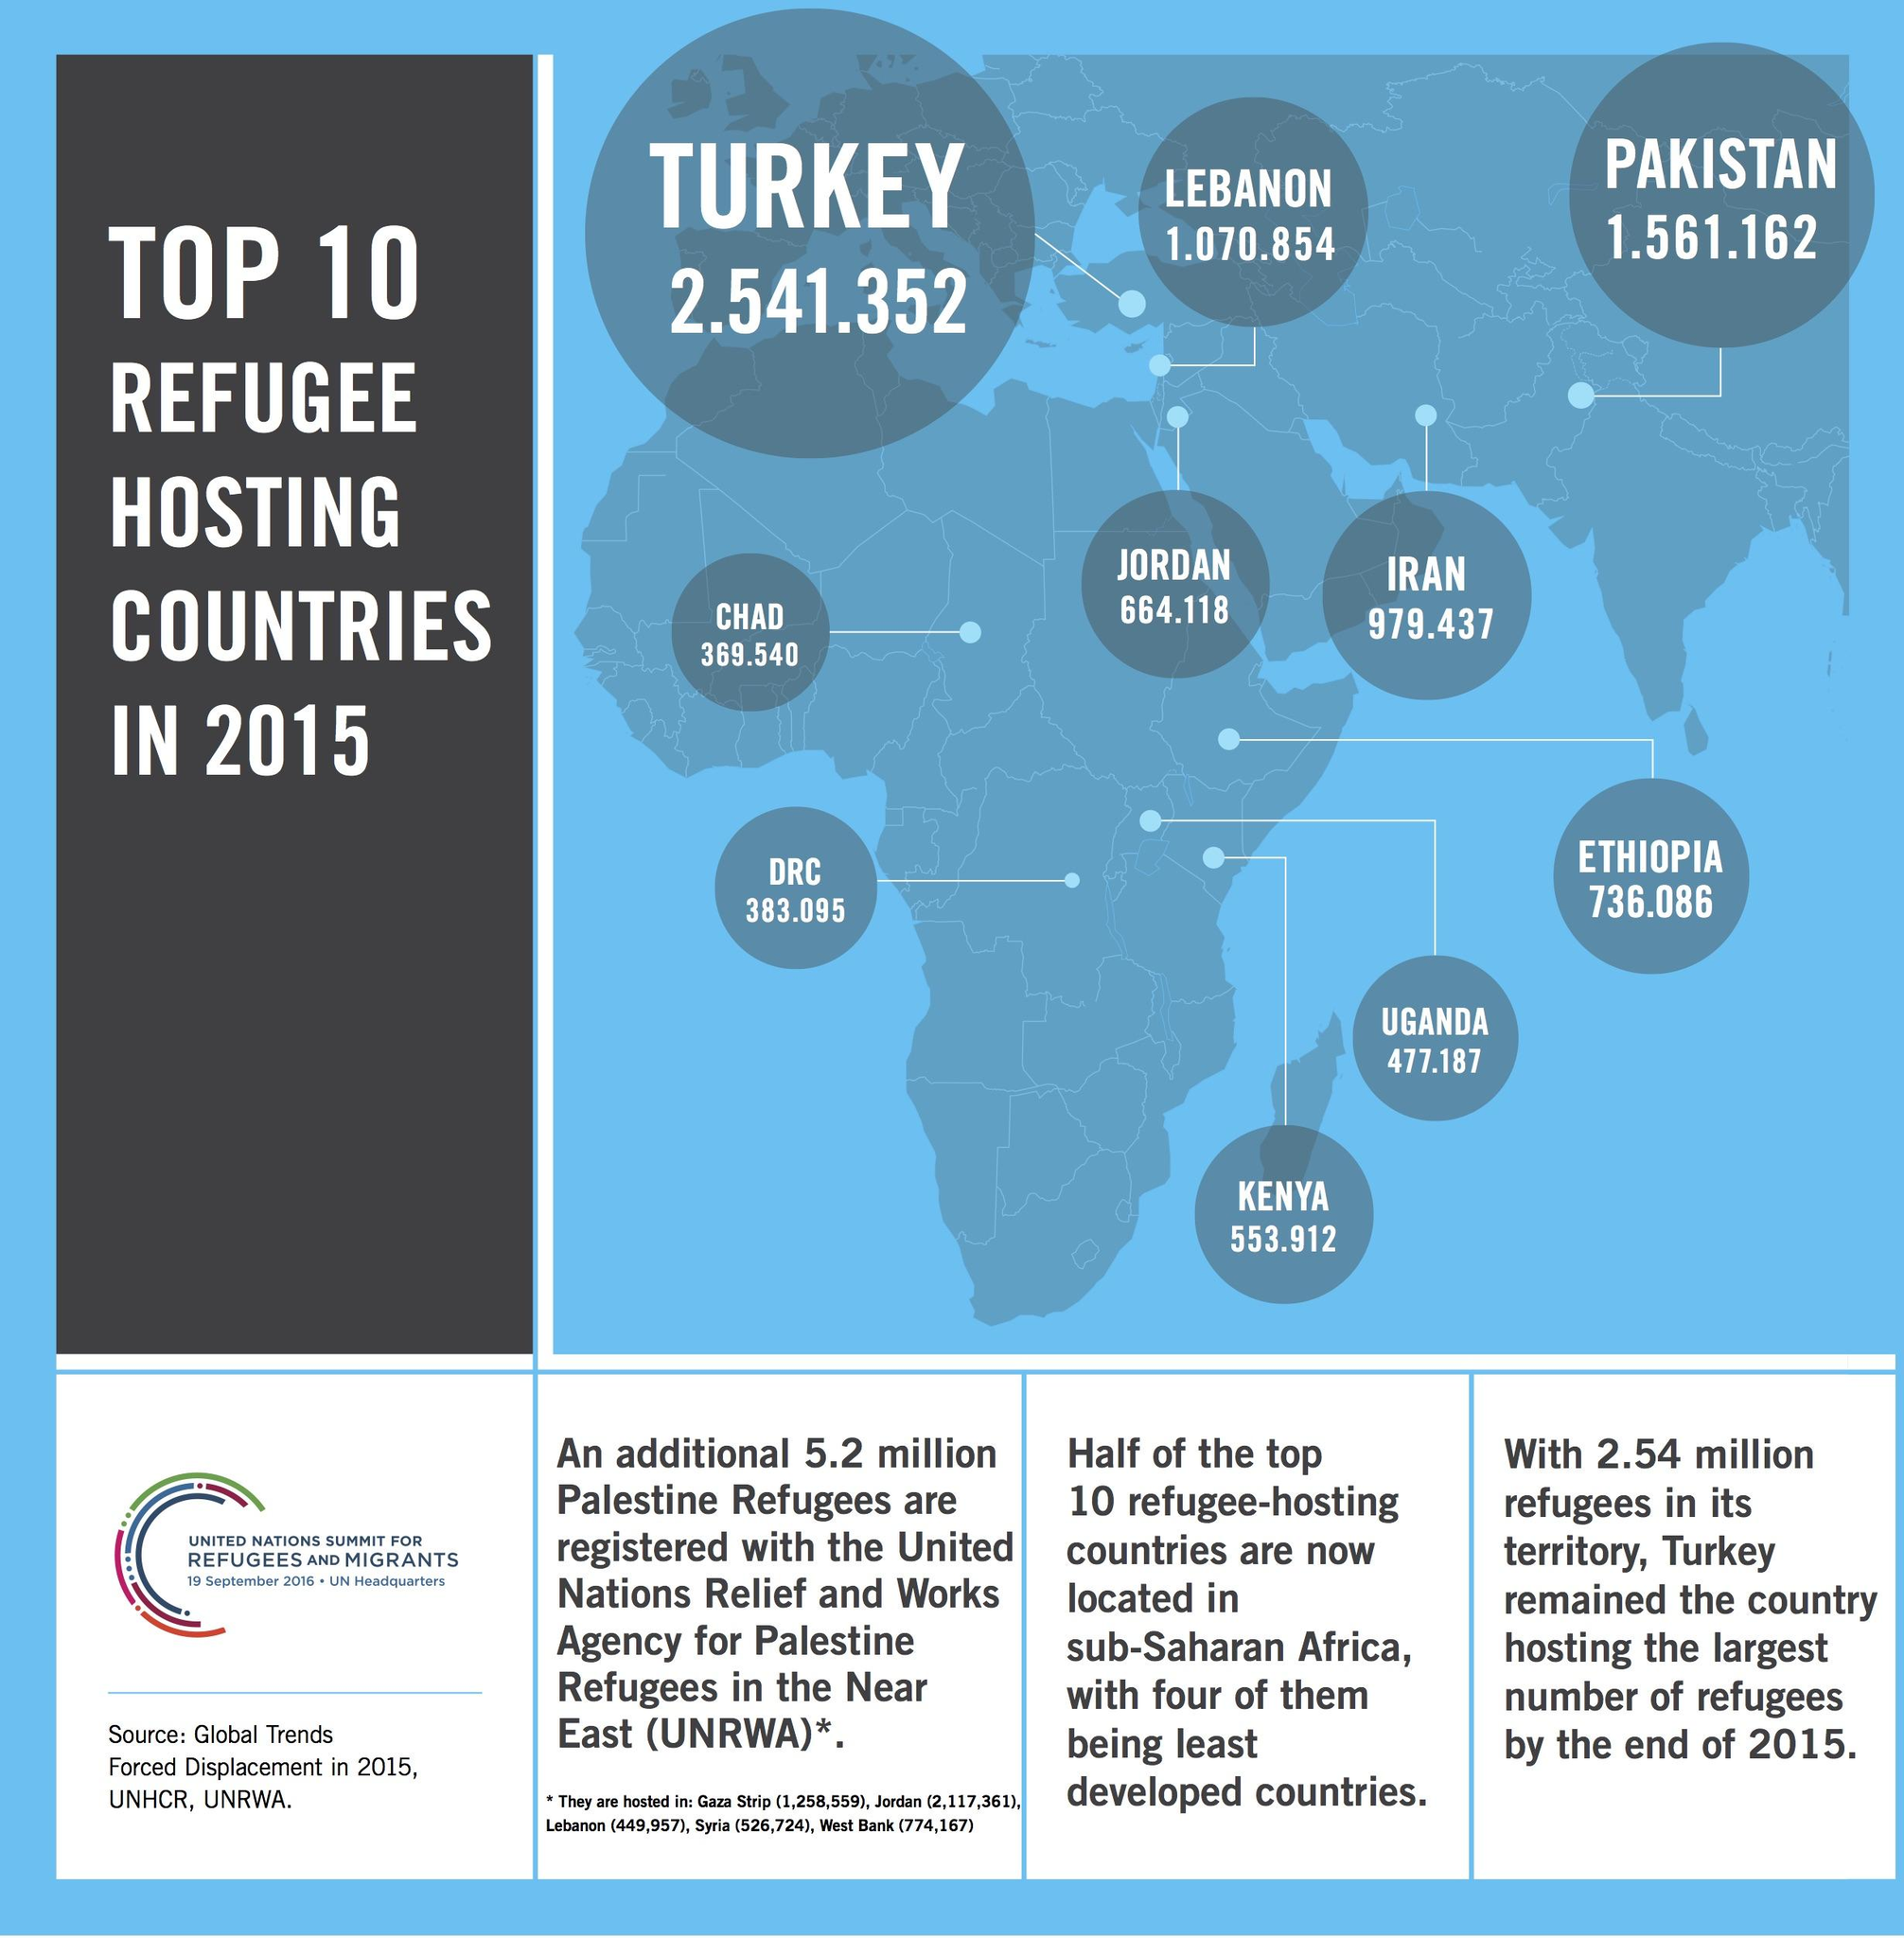Identify some key points in this picture. Pakistan hosted the second highest number of refugees in 2015, according to data. In 2015, Iran hosted a total of 979,437 refugees. Chad, a country in Africa, hosted the least number of refugees in 2015. In 2015, Pakistan hosted a total of 1,561,162 refugees. Turkey hosted the largest number of refugees in 2015. 